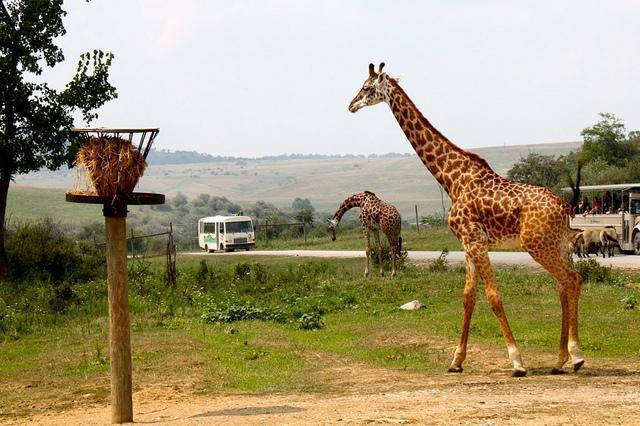What are the people on the vehicle to the right involved in?
Make your selection from the four choices given to correctly answer the question.
Options: Safari, hitch hiking, school ride, selling. Safari. 